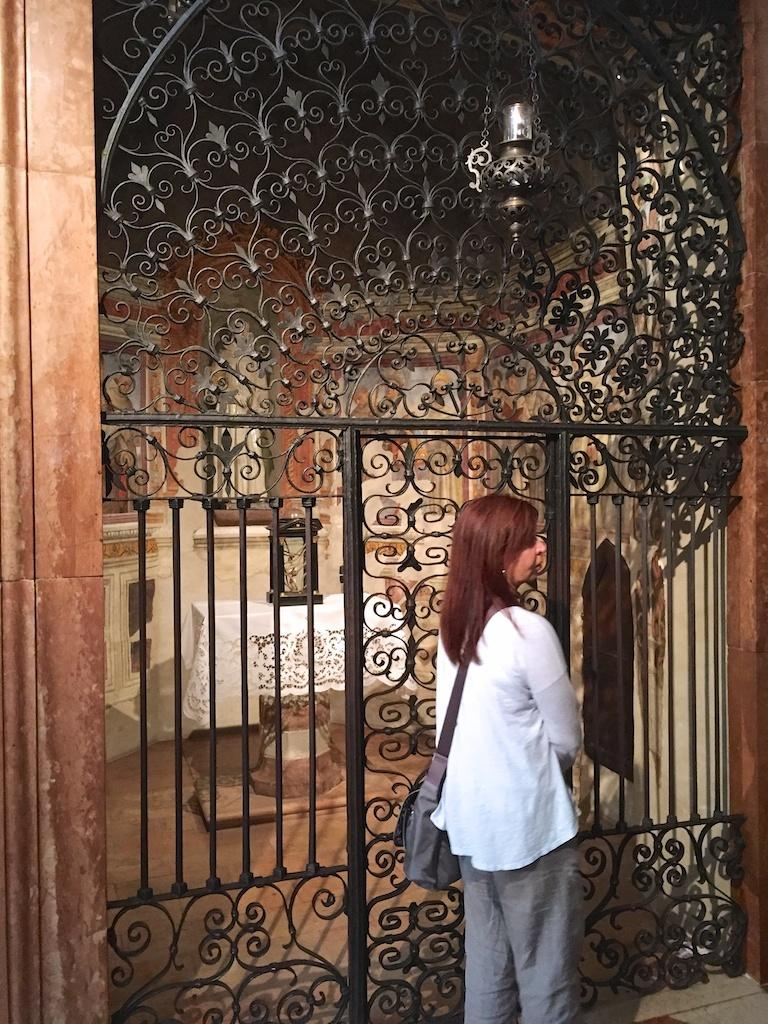What is the main subject in the foreground of the image? There is a woman standing in the foreground of the image. What is the woman wearing in the image? The woman is wearing a bag in the image. What can be seen in the background of the image? There is a grill gate, an object on a table, and a wall visible in the background of the image. What type of dirt can be seen on the woman's shoes in the image? There is no dirt visible on the woman's shoes in the image. How far away is the ocean from the woman in the image? There is no ocean present in the image. 